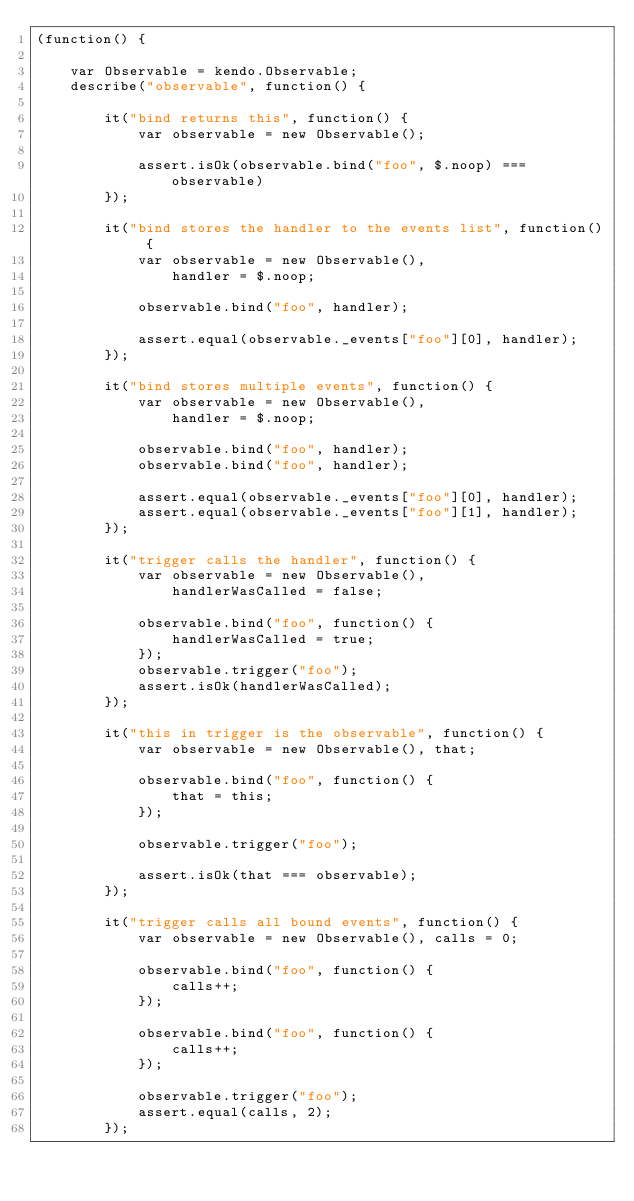Convert code to text. <code><loc_0><loc_0><loc_500><loc_500><_JavaScript_>(function() {

    var Observable = kendo.Observable;
    describe("observable", function() {

        it("bind returns this", function() {
            var observable = new Observable();

            assert.isOk(observable.bind("foo", $.noop) === observable)
        });

        it("bind stores the handler to the events list", function() {
            var observable = new Observable(),
                handler = $.noop;

            observable.bind("foo", handler);

            assert.equal(observable._events["foo"][0], handler);
        });

        it("bind stores multiple events", function() {
            var observable = new Observable(),
                handler = $.noop;

            observable.bind("foo", handler);
            observable.bind("foo", handler);

            assert.equal(observable._events["foo"][0], handler);
            assert.equal(observable._events["foo"][1], handler);
        });

        it("trigger calls the handler", function() {
            var observable = new Observable(),
                handlerWasCalled = false;

            observable.bind("foo", function() {
                handlerWasCalled = true;
            });
            observable.trigger("foo");
            assert.isOk(handlerWasCalled);
        });

        it("this in trigger is the observable", function() {
            var observable = new Observable(), that;

            observable.bind("foo", function() {
                that = this;
            });

            observable.trigger("foo");

            assert.isOk(that === observable);
        });

        it("trigger calls all bound events", function() {
            var observable = new Observable(), calls = 0;

            observable.bind("foo", function() {
                calls++;
            });

            observable.bind("foo", function() {
                calls++;
            });

            observable.trigger("foo");
            assert.equal(calls, 2);
        });
</code> 